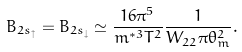<formula> <loc_0><loc_0><loc_500><loc_500>B _ { 2 s _ { \uparrow } } = B _ { 2 s _ { \downarrow } } \simeq \frac { 1 6 \pi ^ { 5 } } { m ^ { * 3 } T ^ { 2 } } \frac { 1 } { W _ { 2 2 } \pi \theta _ { m } ^ { 2 } } .</formula> 